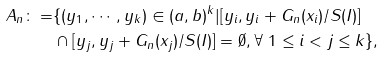<formula> <loc_0><loc_0><loc_500><loc_500>A _ { n } \colon = & \{ ( y _ { 1 } , \cdots , y _ { k } ) \in ( a , b ) ^ { k } | [ y _ { i } , y _ { i } + G _ { n } ( x _ { i } ) / S ( I ) ] \\ & \cap [ y _ { j } , y _ { j } + G _ { n } ( x _ { j } ) / S ( I ) ] = \emptyset , \forall \ 1 \leq i < j \leq k \} ,</formula> 